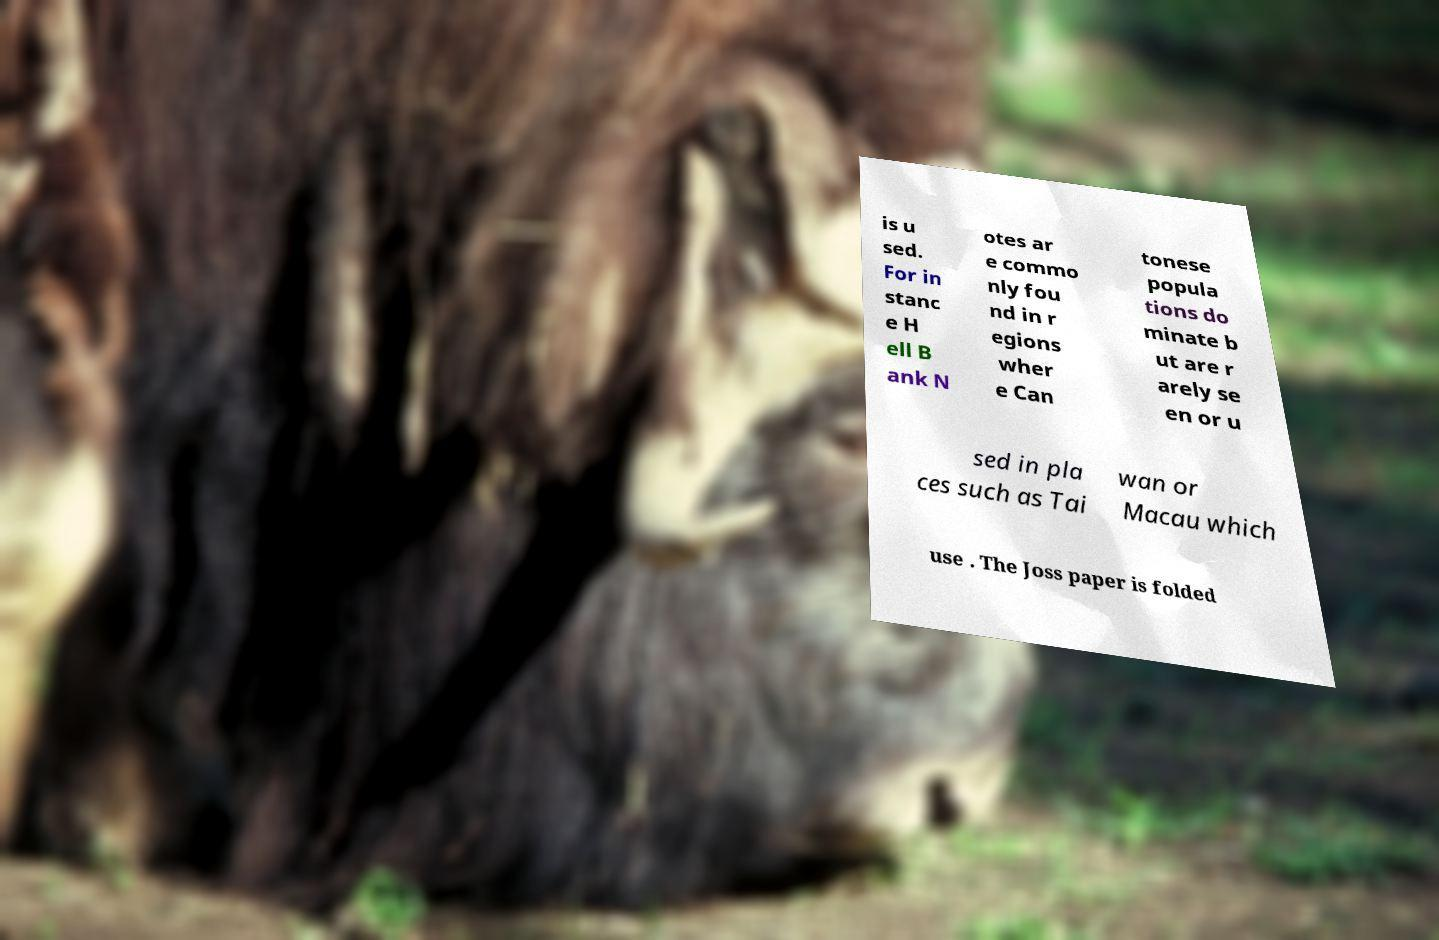Can you read and provide the text displayed in the image?This photo seems to have some interesting text. Can you extract and type it out for me? is u sed. For in stanc e H ell B ank N otes ar e commo nly fou nd in r egions wher e Can tonese popula tions do minate b ut are r arely se en or u sed in pla ces such as Tai wan or Macau which use . The Joss paper is folded 